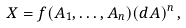<formula> <loc_0><loc_0><loc_500><loc_500>X = f ( A _ { 1 } , \dots , A _ { n } ) ( d A ) ^ { n } \, ,</formula> 